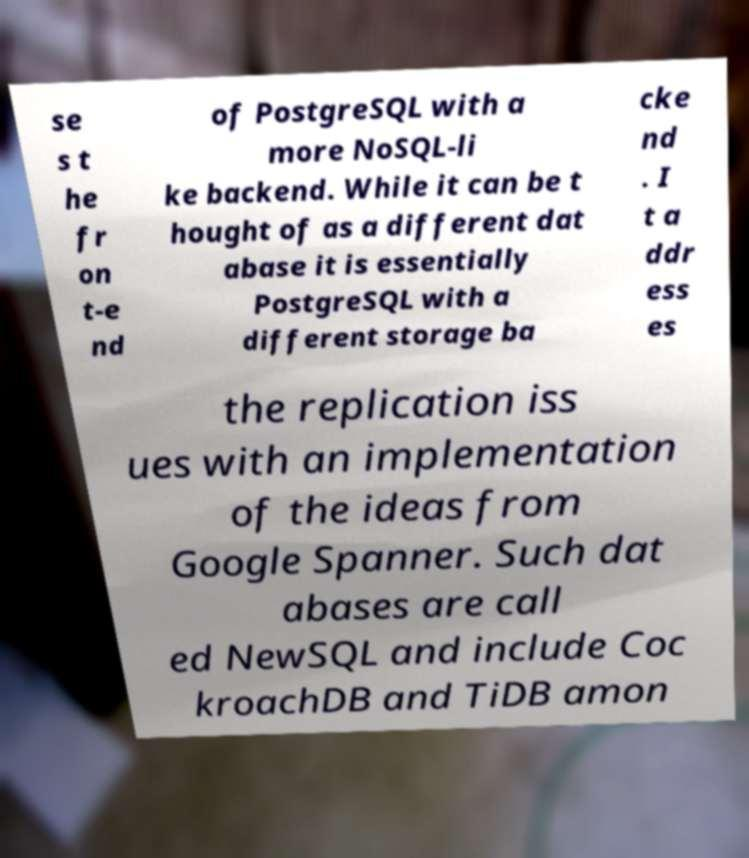Could you assist in decoding the text presented in this image and type it out clearly? se s t he fr on t-e nd of PostgreSQL with a more NoSQL-li ke backend. While it can be t hought of as a different dat abase it is essentially PostgreSQL with a different storage ba cke nd . I t a ddr ess es the replication iss ues with an implementation of the ideas from Google Spanner. Such dat abases are call ed NewSQL and include Coc kroachDB and TiDB amon 